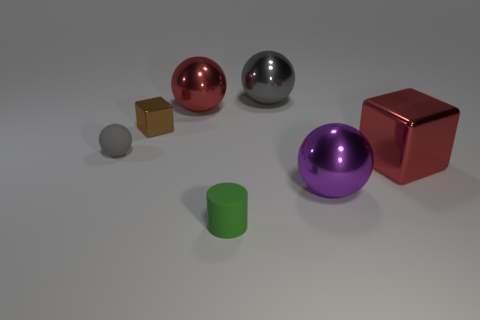What number of cubes are either tiny matte things or small gray things?
Your response must be concise. 0. How many other things are made of the same material as the cylinder?
Make the answer very short. 1. What is the shape of the big red object that is in front of the brown metal cube?
Keep it short and to the point. Cube. The ball in front of the matte object that is behind the purple metallic ball is made of what material?
Offer a very short reply. Metal. Is the number of small blocks on the left side of the purple object greater than the number of big brown matte blocks?
Give a very brief answer. Yes. How many other objects are there of the same color as the matte sphere?
Your answer should be compact. 1. There is a rubber thing that is the same size as the cylinder; what is its shape?
Ensure brevity in your answer.  Sphere. There is a metal block that is to the left of the red thing that is behind the gray matte object; what number of large shiny balls are behind it?
Ensure brevity in your answer.  2. What number of metallic things are small green objects or red balls?
Make the answer very short. 1. There is a sphere that is both behind the red cube and in front of the big red shiny sphere; what is its color?
Provide a succinct answer. Gray. 